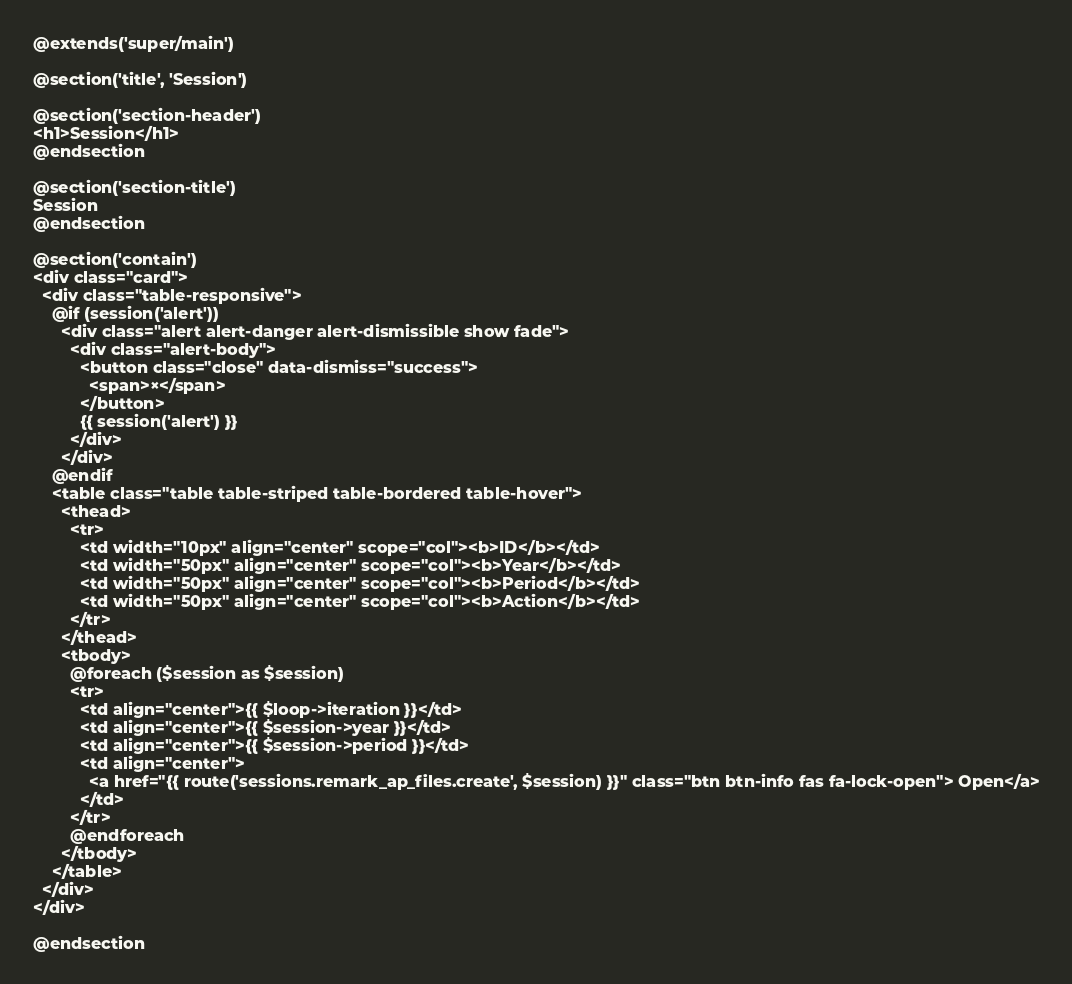<code> <loc_0><loc_0><loc_500><loc_500><_PHP_>@extends('super/main')

@section('title', 'Session')

@section('section-header')
<h1>Session</h1>
@endsection

@section('section-title')
Session    
@endsection

@section('contain')
<div class="card">
  <div class="table-responsive">
    @if (session('alert'))
      <div class="alert alert-danger alert-dismissible show fade">
        <div class="alert-body">
          <button class="close" data-dismiss="success">
            <span>×</span>
          </button>
          {{ session('alert') }}
        </div>
      </div>
    @endif
    <table class="table table-striped table-bordered table-hover">
      <thead>
        <tr>
          <td width="10px" align="center" scope="col"><b>ID</b></td>
          <td width="50px" align="center" scope="col"><b>Year</b></td>
          <td width="50px" align="center" scope="col"><b>Period</b></td>
          <td width="50px" align="center" scope="col"><b>Action</b></td>
        </tr>
      </thead>
      <tbody>
        @foreach ($session as $session)
        <tr>
          <td align="center">{{ $loop->iteration }}</td>
          <td align="center">{{ $session->year }}</td>
          <td align="center">{{ $session->period }}</td>
          <td align="center">
            <a href="{{ route('sessions.remark_ap_files.create', $session) }}" class="btn btn-info fas fa-lock-open"> Open</a>
          </td>
        </tr>
        @endforeach
      </tbody>
    </table>
  </div>
</div>

@endsection</code> 